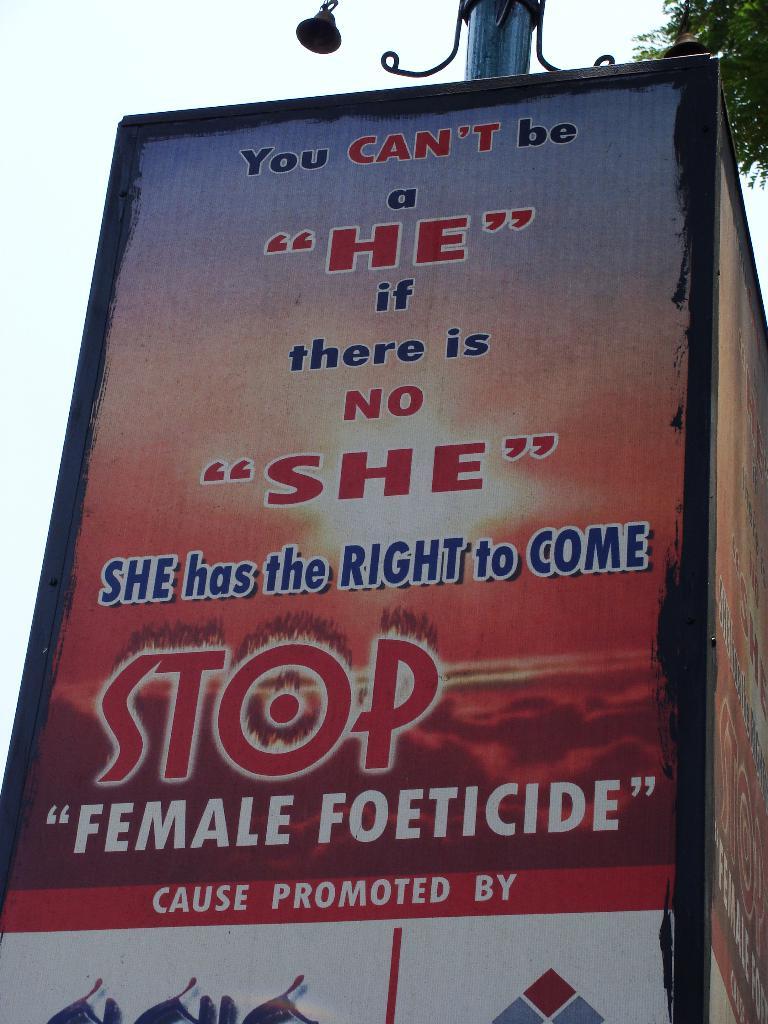What kind of foeticide does the poster have on it?
Give a very brief answer. Female. 